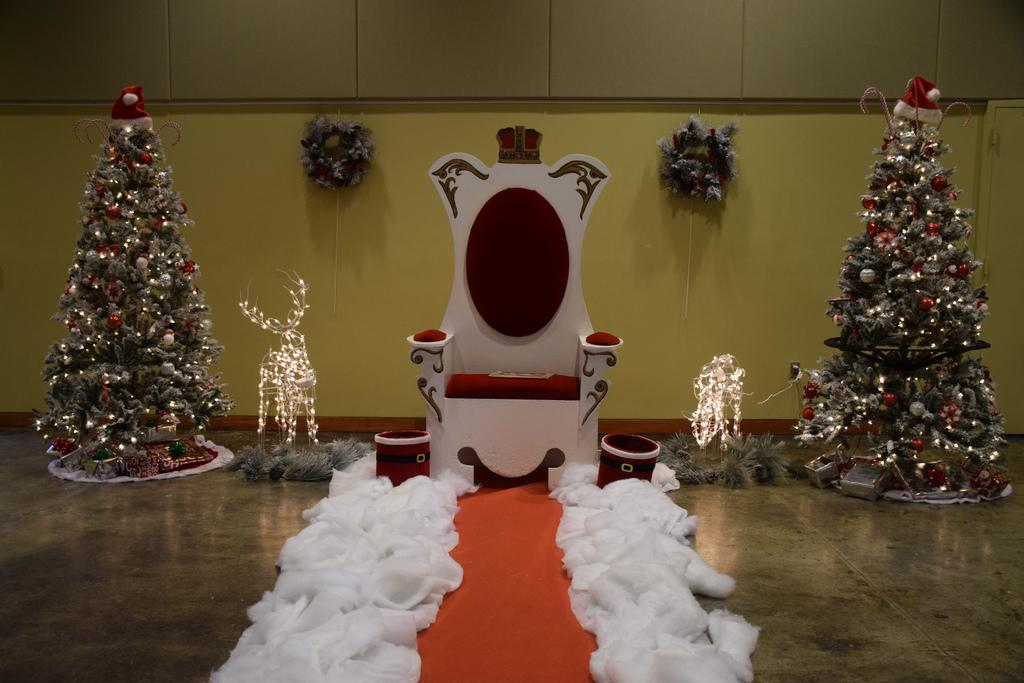What type of furniture is in the image? There is a chair in the image. What holiday decorations are present in the image? There are Christmas trees in the image. What else can be seen in the image besides the chair and Christmas trees? Clothes, lights, and flower bouquets are visible in the image. What part of the room can be seen in the image? The floor is visible in the image. What is in the background of the image? There is a wall in the background of the image. How many bottles of water are visible in the image? There are no bottles of water present in the image. What type of food is being served in the image? There is no food visible in the image. 